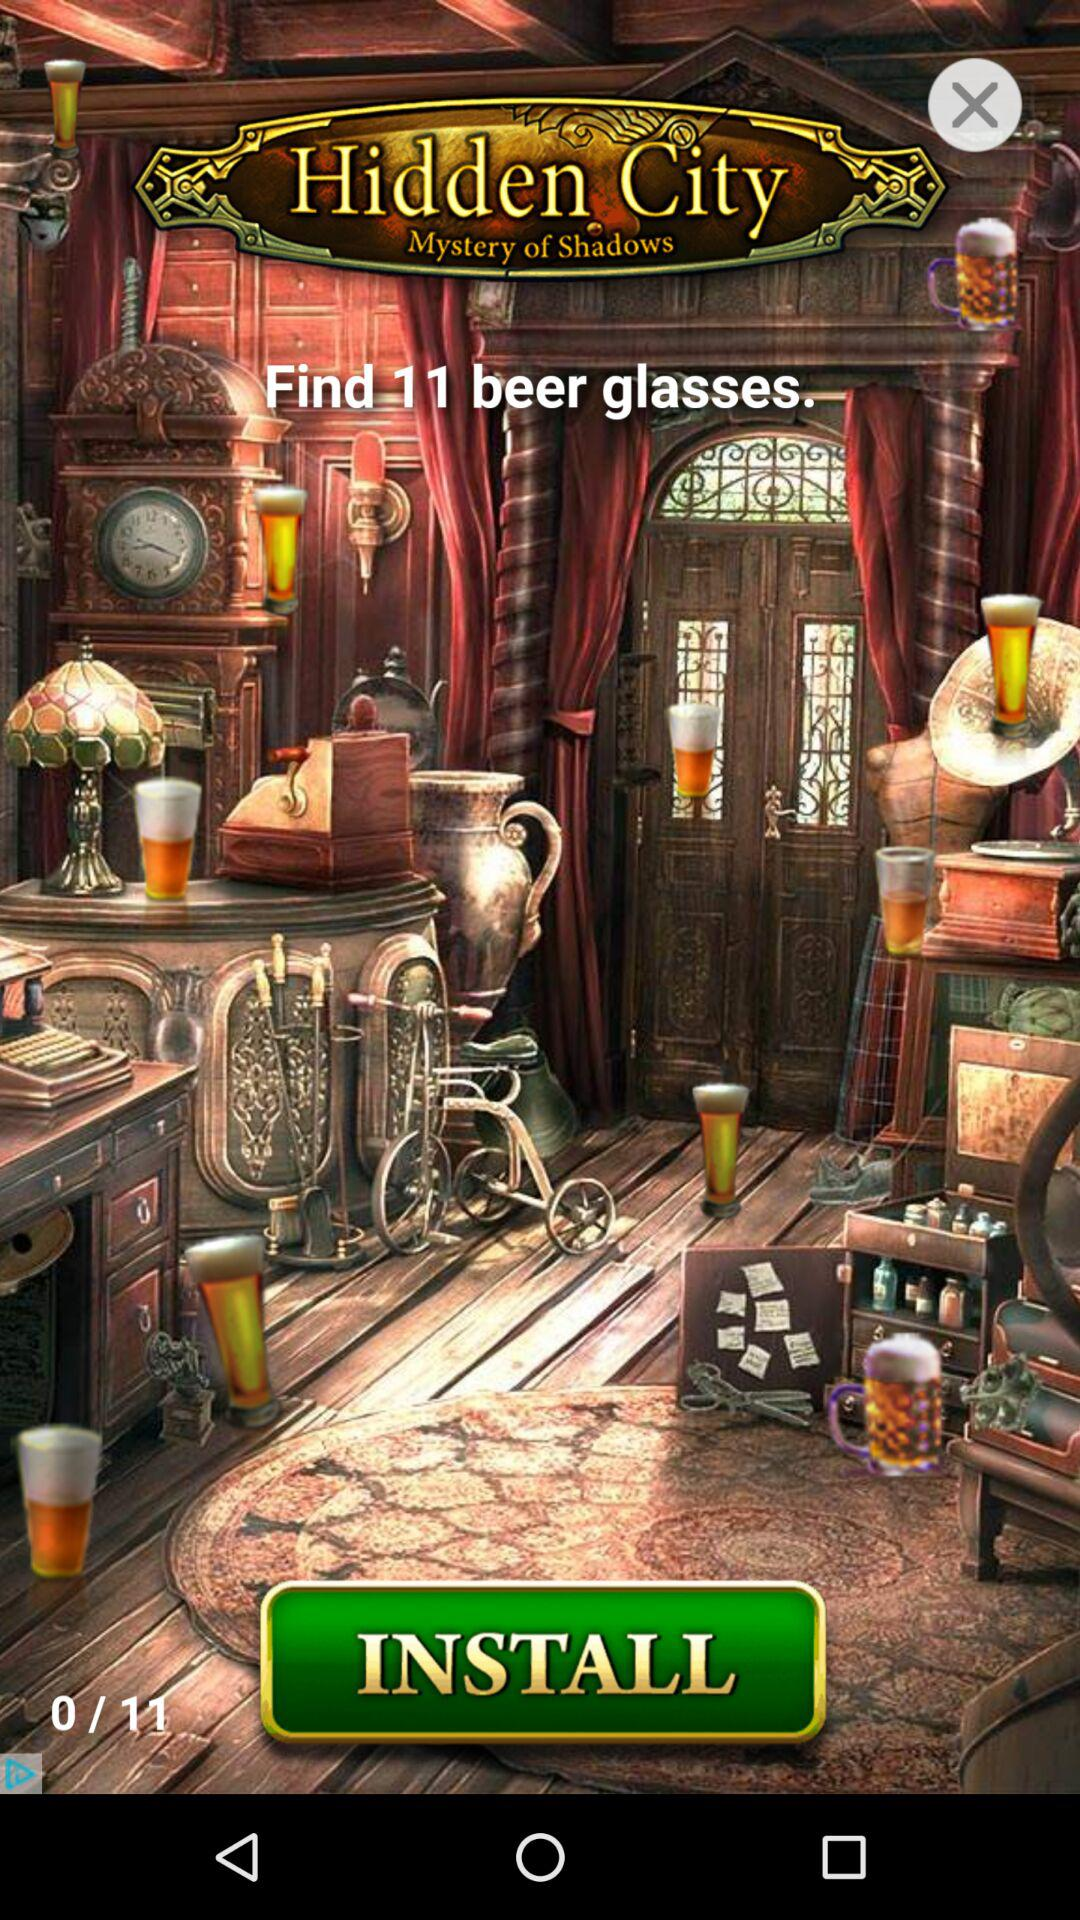How many more beer glasses do I need to find?
Answer the question using a single word or phrase. 11 